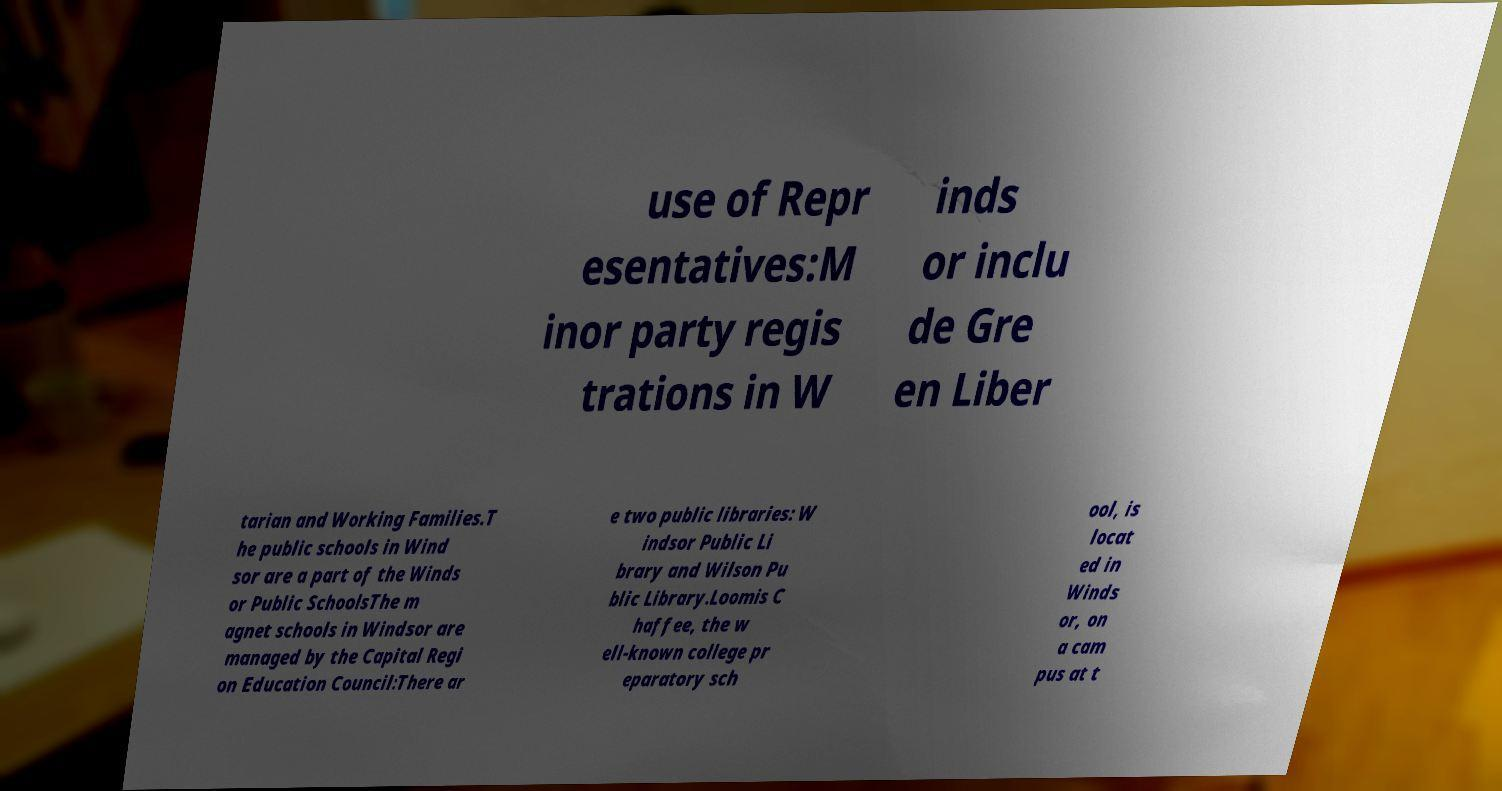Please read and relay the text visible in this image. What does it say? use of Repr esentatives:M inor party regis trations in W inds or inclu de Gre en Liber tarian and Working Families.T he public schools in Wind sor are a part of the Winds or Public SchoolsThe m agnet schools in Windsor are managed by the Capital Regi on Education Council:There ar e two public libraries: W indsor Public Li brary and Wilson Pu blic Library.Loomis C haffee, the w ell-known college pr eparatory sch ool, is locat ed in Winds or, on a cam pus at t 